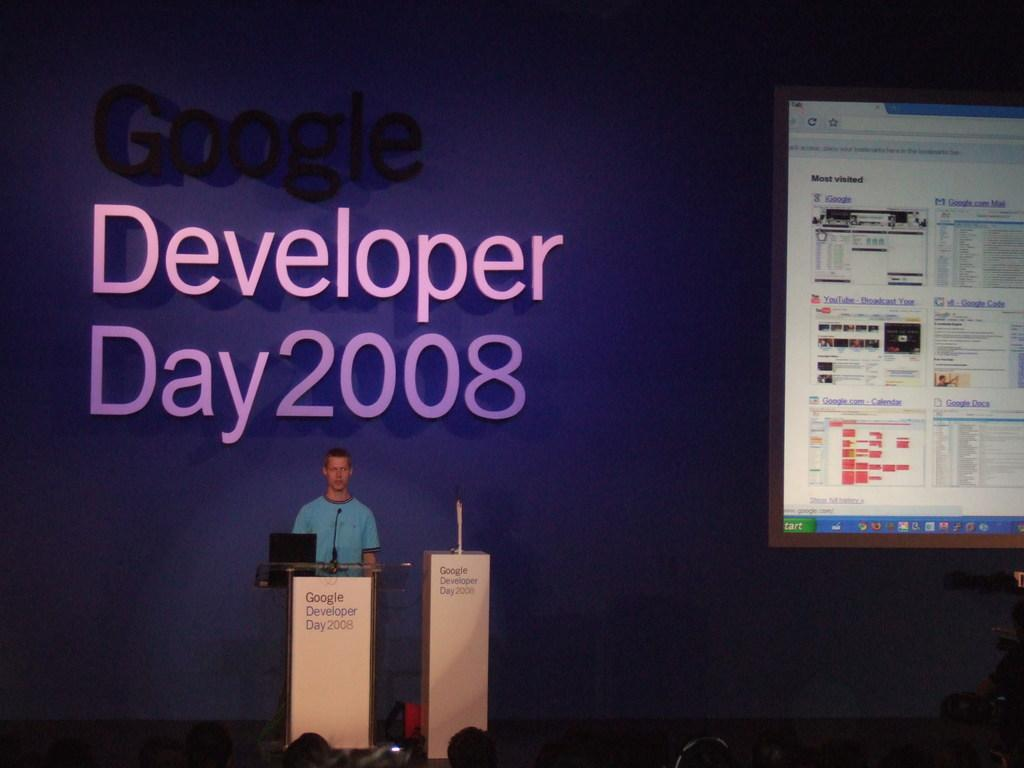<image>
Share a concise interpretation of the image provided. Man giving a presentation in front of a podium that says Google Developer Day 2008. 